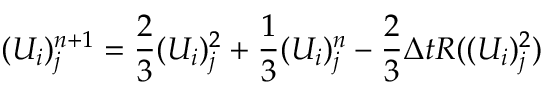<formula> <loc_0><loc_0><loc_500><loc_500>( U _ { i } ) _ { j } ^ { n + 1 } = \frac { 2 } { 3 } ( U _ { i } ) _ { j } ^ { 2 } + \frac { 1 } { 3 } ( U _ { i } ) _ { j } ^ { n } - \frac { 2 } { 3 } \Delta t R ( ( U _ { i } ) _ { j } ^ { 2 } )</formula> 